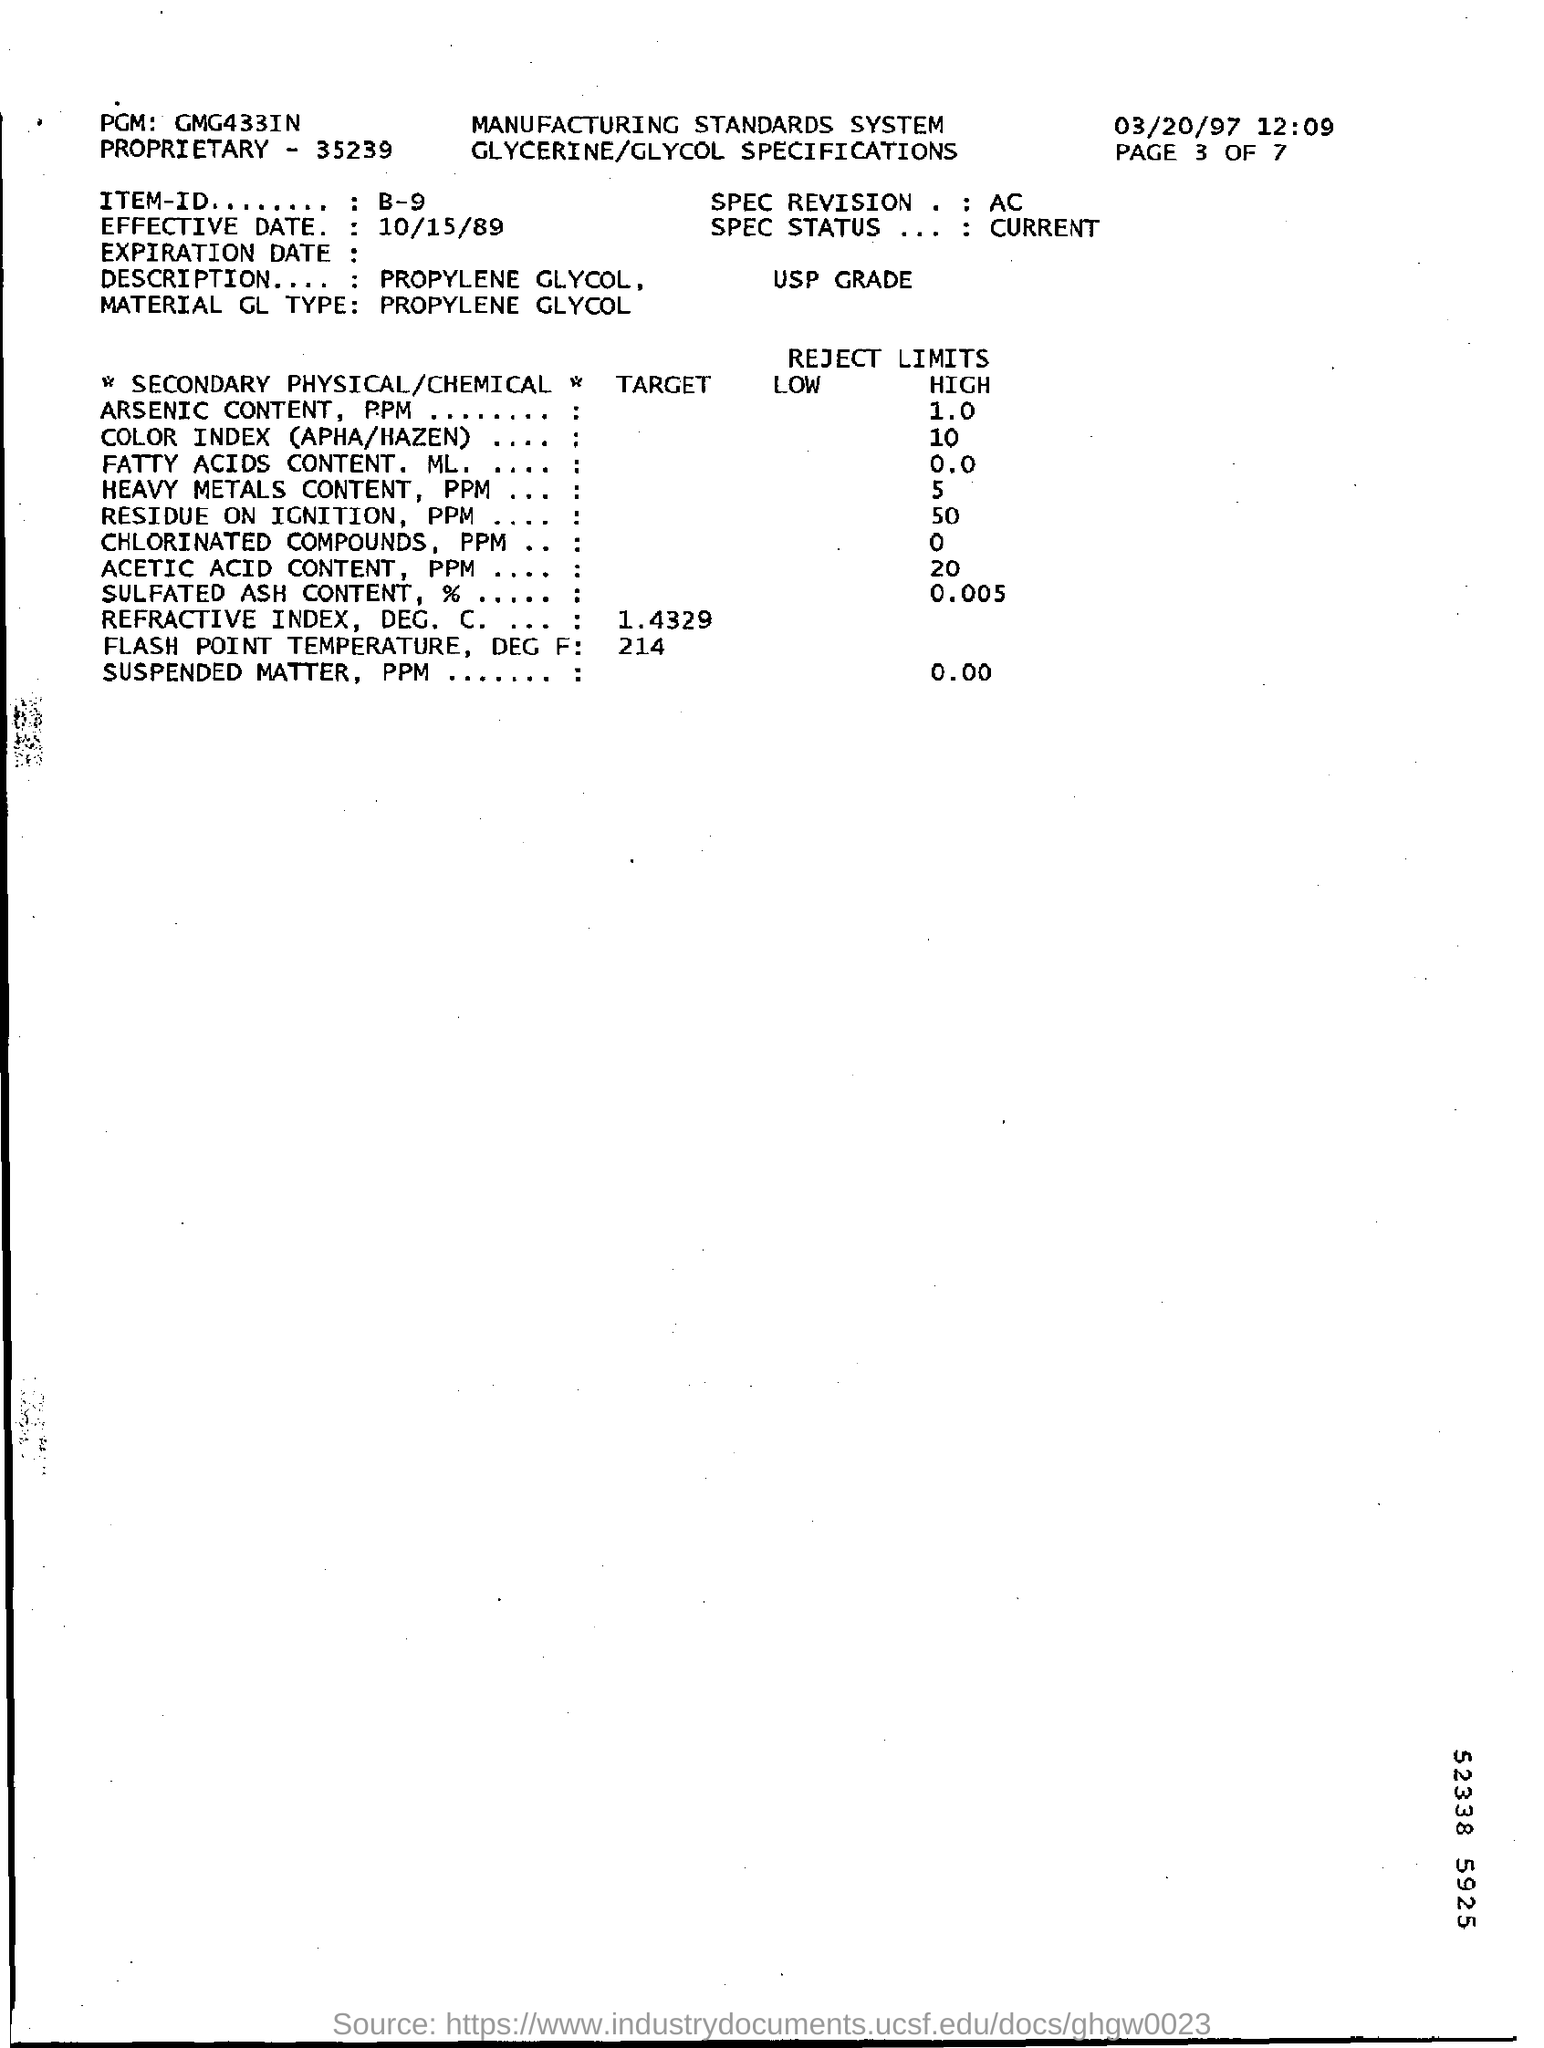Highlight a few significant elements in this photo. The page number of the document is 3 out of 7. The "item ID" mentioned in the document is B-9. The document mentions the time as 12.09...," the speaker declared. 